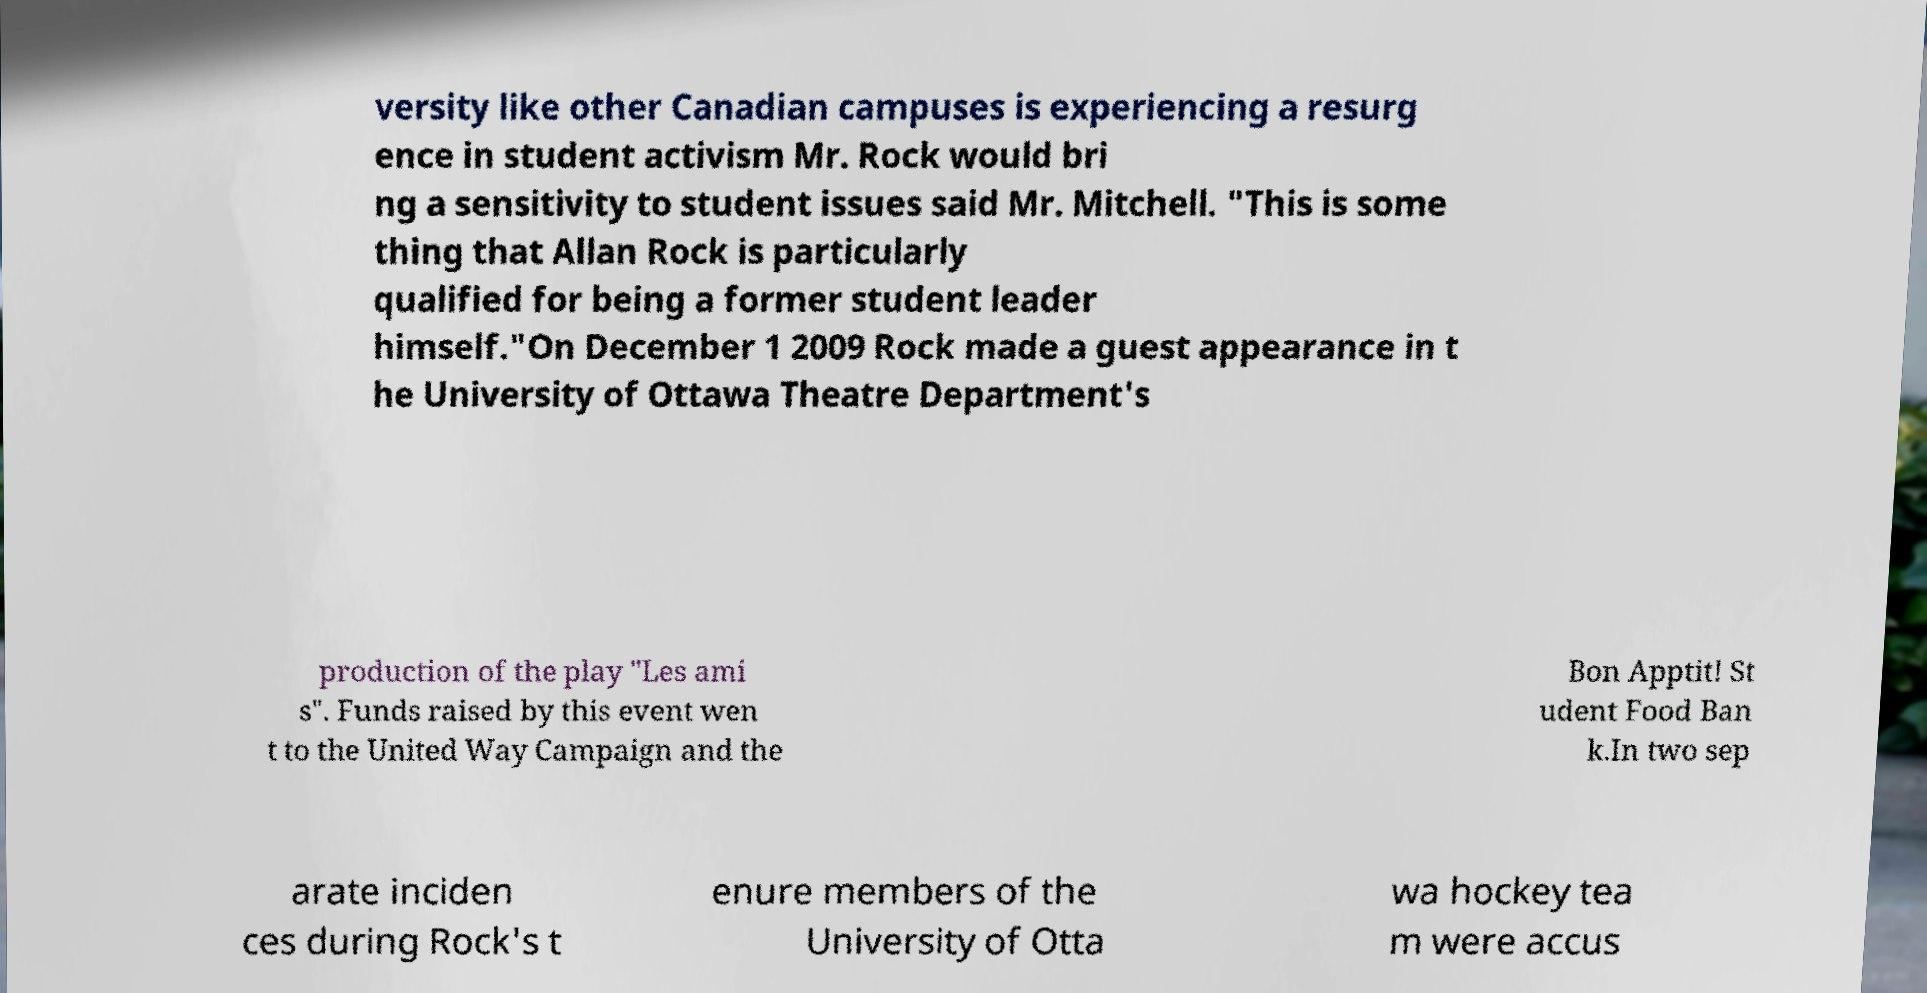I need the written content from this picture converted into text. Can you do that? versity like other Canadian campuses is experiencing a resurg ence in student activism Mr. Rock would bri ng a sensitivity to student issues said Mr. Mitchell. "This is some thing that Allan Rock is particularly qualified for being a former student leader himself."On December 1 2009 Rock made a guest appearance in t he University of Ottawa Theatre Department's production of the play "Les ami s". Funds raised by this event wen t to the United Way Campaign and the Bon Apptit! St udent Food Ban k.In two sep arate inciden ces during Rock's t enure members of the University of Otta wa hockey tea m were accus 